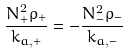Convert formula to latex. <formula><loc_0><loc_0><loc_500><loc_500>\frac { N ^ { 2 } _ { + } \rho _ { + } } { k _ { a , + } } = - \frac { N ^ { 2 } _ { - } \rho _ { - } } { k _ { a , - } }</formula> 